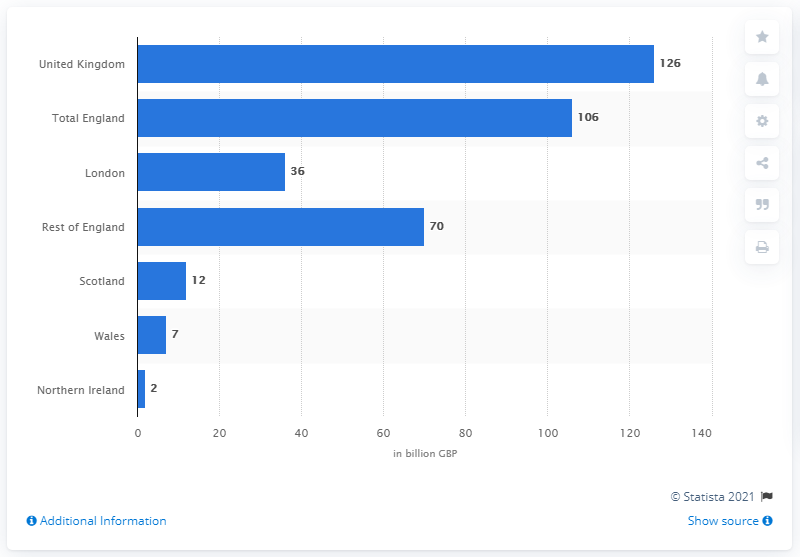Indicate a few pertinent items in this graphic. In 2013, the tourism sector contributed approximately 126% to the UK's Gross Domestic Product (GDP). The Gross Domestic Product (GDP) of England in 2013 was $106 billion. 